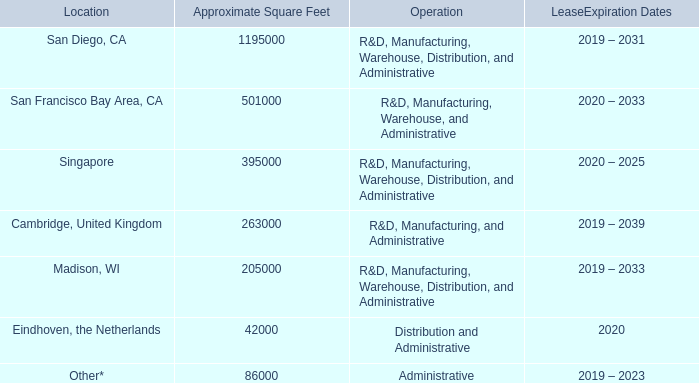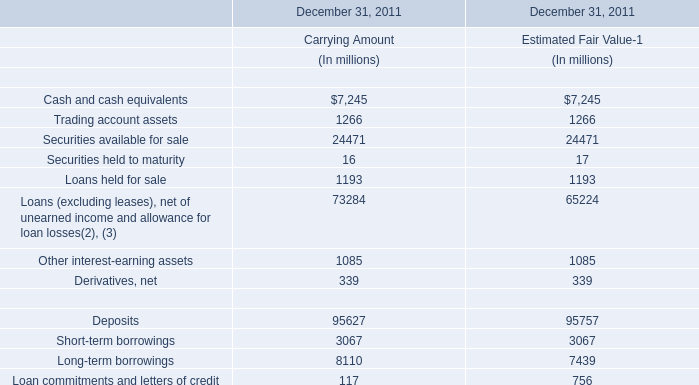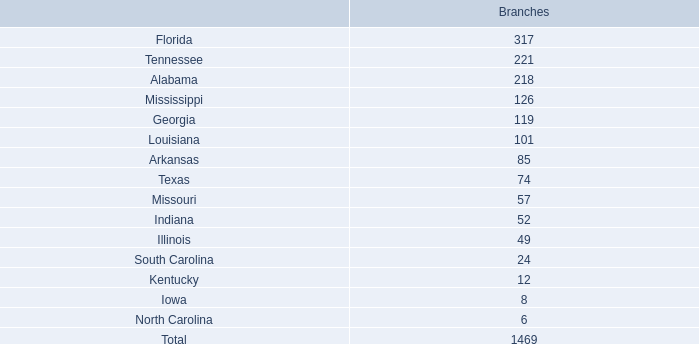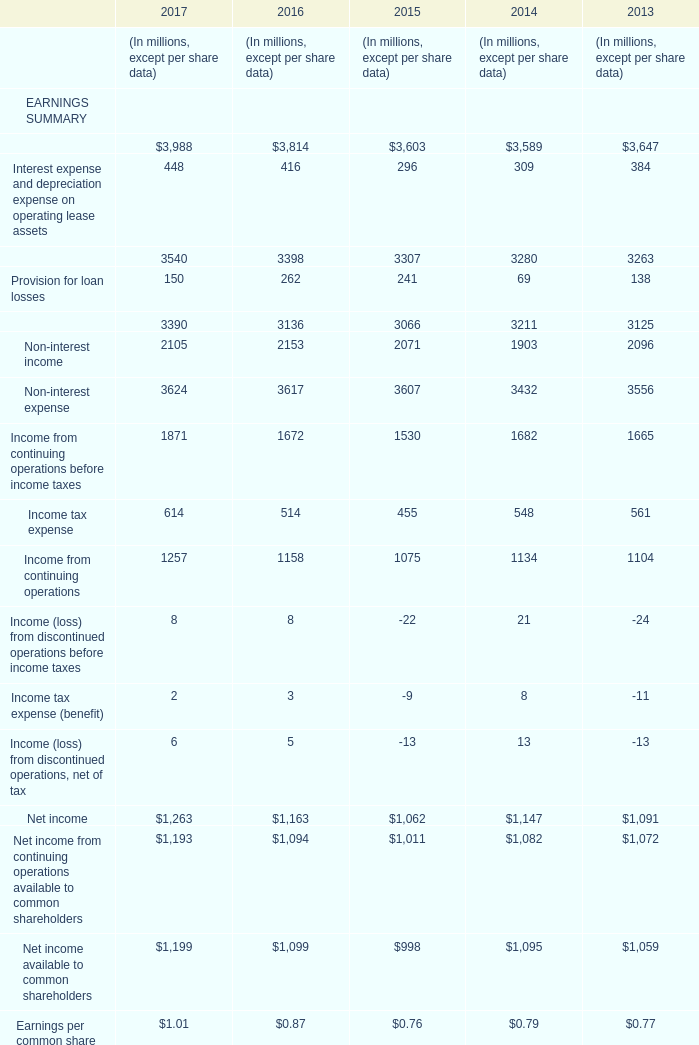The total amount of which section ranks first in 2017? 
Answer: Assets. 